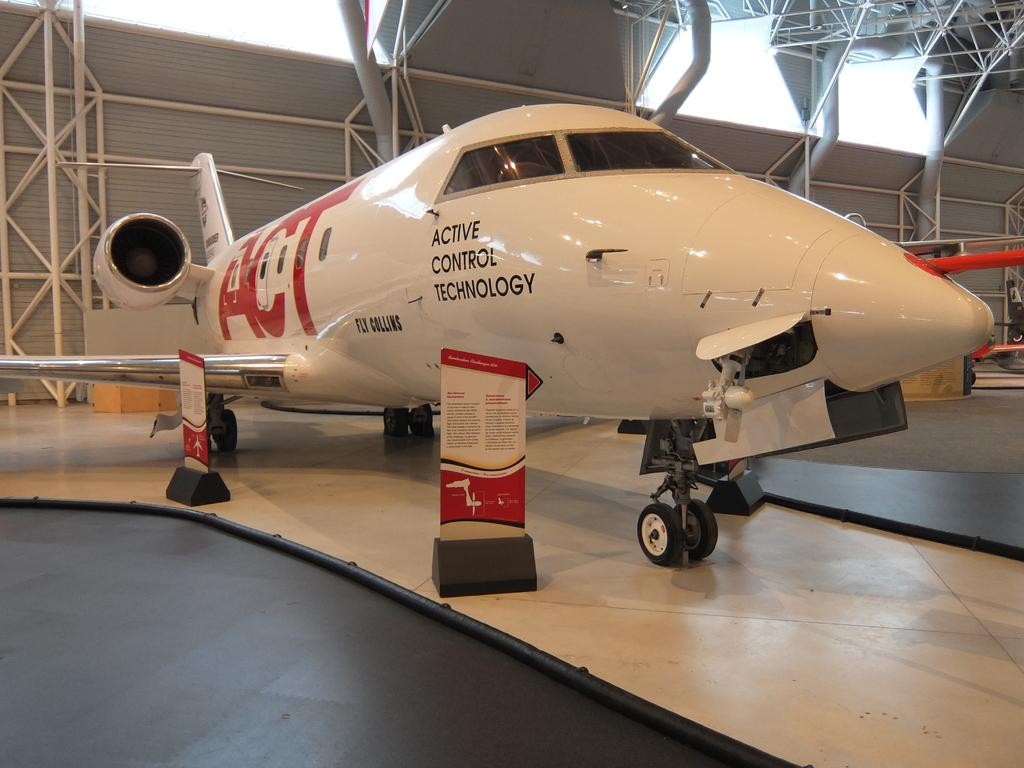<image>
Describe the image concisely. An active control technology plane sits inside a building. 